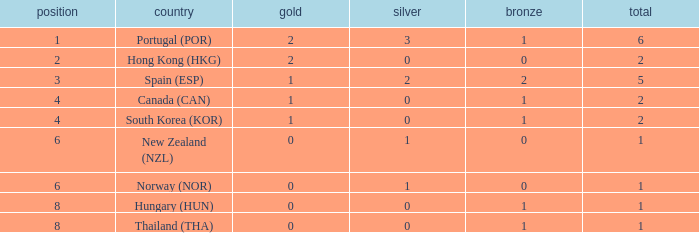Which Rank number has a Silver of 0, Gold of 2 and total smaller than 2? 0.0. Could you help me parse every detail presented in this table? {'header': ['position', 'country', 'gold', 'silver', 'bronze', 'total'], 'rows': [['1', 'Portugal (POR)', '2', '3', '1', '6'], ['2', 'Hong Kong (HKG)', '2', '0', '0', '2'], ['3', 'Spain (ESP)', '1', '2', '2', '5'], ['4', 'Canada (CAN)', '1', '0', '1', '2'], ['4', 'South Korea (KOR)', '1', '0', '1', '2'], ['6', 'New Zealand (NZL)', '0', '1', '0', '1'], ['6', 'Norway (NOR)', '0', '1', '0', '1'], ['8', 'Hungary (HUN)', '0', '0', '1', '1'], ['8', 'Thailand (THA)', '0', '0', '1', '1']]} 